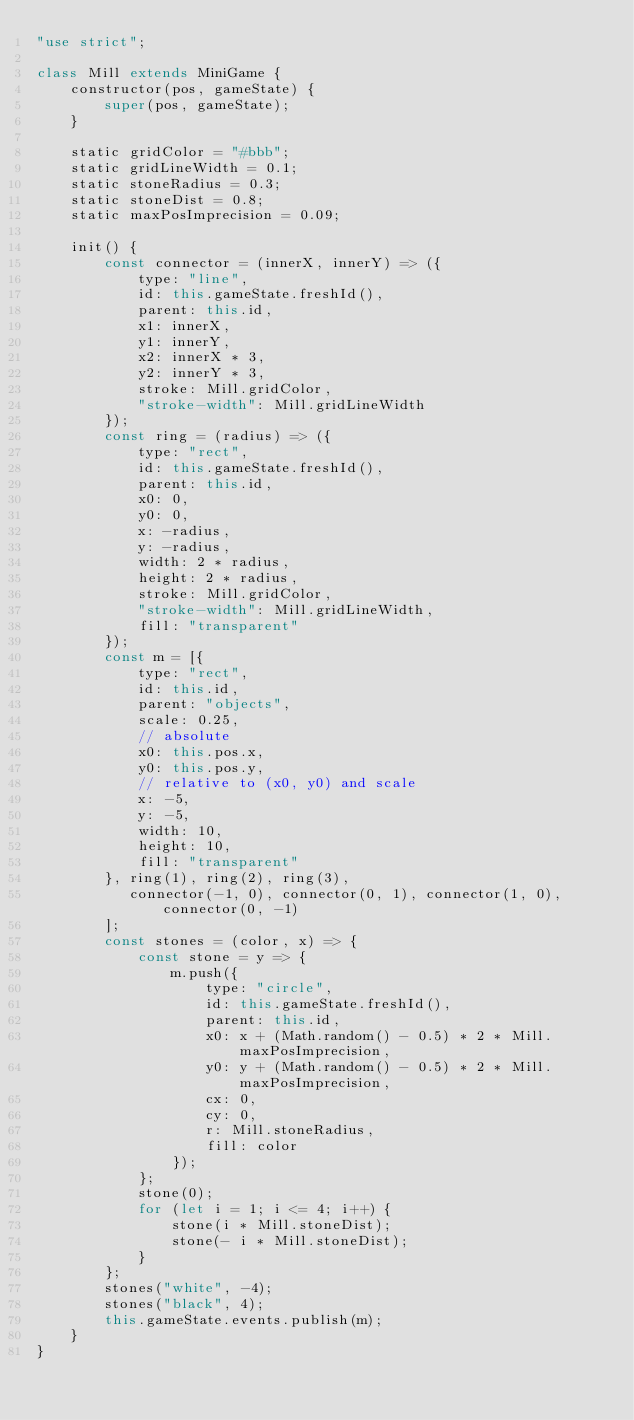<code> <loc_0><loc_0><loc_500><loc_500><_JavaScript_>"use strict";

class Mill extends MiniGame {
    constructor(pos, gameState) {
        super(pos, gameState);
    }

    static gridColor = "#bbb";
    static gridLineWidth = 0.1;
    static stoneRadius = 0.3;
    static stoneDist = 0.8;
    static maxPosImprecision = 0.09;

    init() {
        const connector = (innerX, innerY) => ({
            type: "line",
            id: this.gameState.freshId(),
            parent: this.id,
            x1: innerX,
            y1: innerY,
            x2: innerX * 3,
            y2: innerY * 3,
            stroke: Mill.gridColor,
            "stroke-width": Mill.gridLineWidth
        });
        const ring = (radius) => ({
            type: "rect",
            id: this.gameState.freshId(),
            parent: this.id,
            x0: 0,
            y0: 0,
            x: -radius,
            y: -radius,
            width: 2 * radius,
            height: 2 * radius,
            stroke: Mill.gridColor,
            "stroke-width": Mill.gridLineWidth,
            fill: "transparent"
        });
        const m = [{
            type: "rect",
            id: this.id,
            parent: "objects",
            scale: 0.25,
            // absolute
            x0: this.pos.x,
            y0: this.pos.y,
            // relative to (x0, y0) and scale
            x: -5,
            y: -5,
            width: 10,
            height: 10,
            fill: "transparent"
        }, ring(1), ring(2), ring(3), 
           connector(-1, 0), connector(0, 1), connector(1, 0), connector(0, -1)
        ];
        const stones = (color, x) => {
            const stone = y => {
                m.push({
                    type: "circle",
                    id: this.gameState.freshId(),
                    parent: this.id,
                    x0: x + (Math.random() - 0.5) * 2 * Mill.maxPosImprecision,
                    y0: y + (Math.random() - 0.5) * 2 * Mill.maxPosImprecision,
                    cx: 0,
                    cy: 0,
                    r: Mill.stoneRadius,
                    fill: color
                });
            };
            stone(0);
            for (let i = 1; i <= 4; i++) {
                stone(i * Mill.stoneDist);
                stone(- i * Mill.stoneDist);
            }
        };
        stones("white", -4);
        stones("black", 4);
        this.gameState.events.publish(m);
    }
}
</code> 